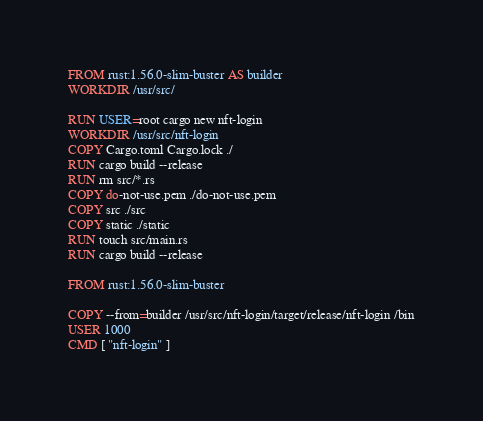<code> <loc_0><loc_0><loc_500><loc_500><_Dockerfile_>FROM rust:1.56.0-slim-buster AS builder
WORKDIR /usr/src/

RUN USER=root cargo new nft-login
WORKDIR /usr/src/nft-login
COPY Cargo.toml Cargo.lock ./
RUN cargo build --release
RUN rm src/*.rs
COPY do-not-use.pem ./do-not-use.pem
COPY src ./src
COPY static ./static
RUN touch src/main.rs
RUN cargo build --release

FROM rust:1.56.0-slim-buster

COPY --from=builder /usr/src/nft-login/target/release/nft-login /bin
USER 1000
CMD [ "nft-login" ]
</code> 